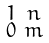<formula> <loc_0><loc_0><loc_500><loc_500>\begin{smallmatrix} 1 & n \\ 0 & m \end{smallmatrix}</formula> 